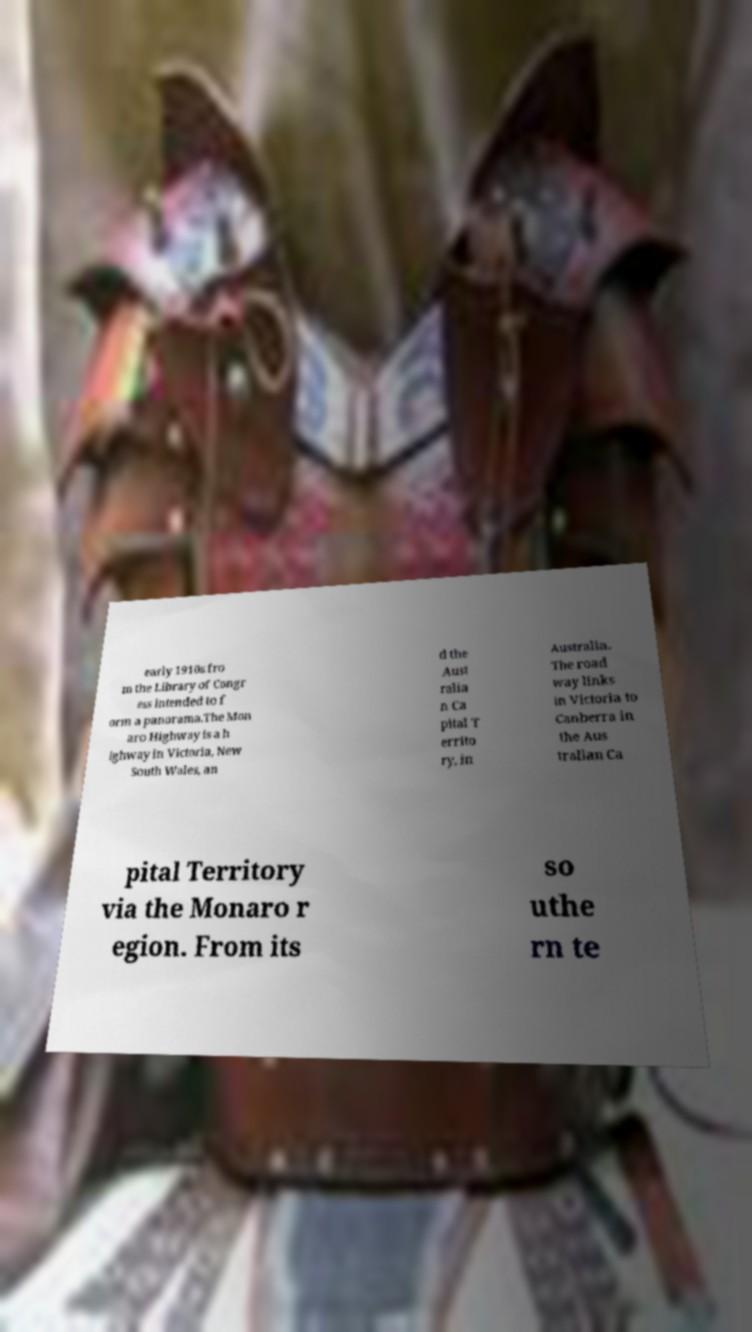I need the written content from this picture converted into text. Can you do that? early 1910s fro m the Library of Congr ess intended to f orm a panorama.The Mon aro Highway is a h ighway in Victoria, New South Wales, an d the Aust ralia n Ca pital T errito ry, in Australia. The road way links in Victoria to Canberra in the Aus tralian Ca pital Territory via the Monaro r egion. From its so uthe rn te 